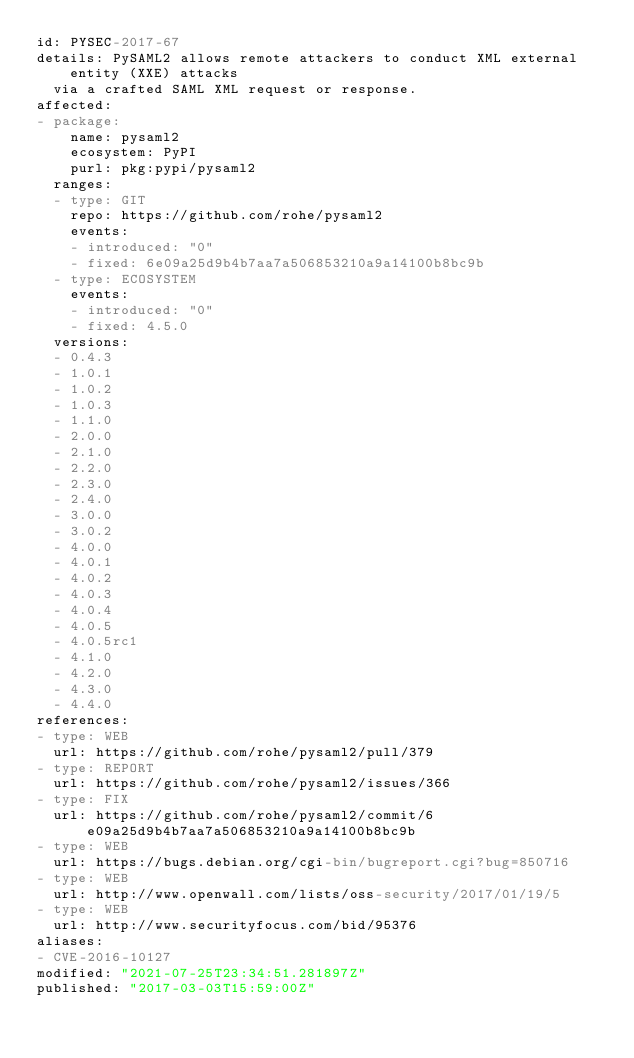Convert code to text. <code><loc_0><loc_0><loc_500><loc_500><_YAML_>id: PYSEC-2017-67
details: PySAML2 allows remote attackers to conduct XML external entity (XXE) attacks
  via a crafted SAML XML request or response.
affected:
- package:
    name: pysaml2
    ecosystem: PyPI
    purl: pkg:pypi/pysaml2
  ranges:
  - type: GIT
    repo: https://github.com/rohe/pysaml2
    events:
    - introduced: "0"
    - fixed: 6e09a25d9b4b7aa7a506853210a9a14100b8bc9b
  - type: ECOSYSTEM
    events:
    - introduced: "0"
    - fixed: 4.5.0
  versions:
  - 0.4.3
  - 1.0.1
  - 1.0.2
  - 1.0.3
  - 1.1.0
  - 2.0.0
  - 2.1.0
  - 2.2.0
  - 2.3.0
  - 2.4.0
  - 3.0.0
  - 3.0.2
  - 4.0.0
  - 4.0.1
  - 4.0.2
  - 4.0.3
  - 4.0.4
  - 4.0.5
  - 4.0.5rc1
  - 4.1.0
  - 4.2.0
  - 4.3.0
  - 4.4.0
references:
- type: WEB
  url: https://github.com/rohe/pysaml2/pull/379
- type: REPORT
  url: https://github.com/rohe/pysaml2/issues/366
- type: FIX
  url: https://github.com/rohe/pysaml2/commit/6e09a25d9b4b7aa7a506853210a9a14100b8bc9b
- type: WEB
  url: https://bugs.debian.org/cgi-bin/bugreport.cgi?bug=850716
- type: WEB
  url: http://www.openwall.com/lists/oss-security/2017/01/19/5
- type: WEB
  url: http://www.securityfocus.com/bid/95376
aliases:
- CVE-2016-10127
modified: "2021-07-25T23:34:51.281897Z"
published: "2017-03-03T15:59:00Z"
</code> 